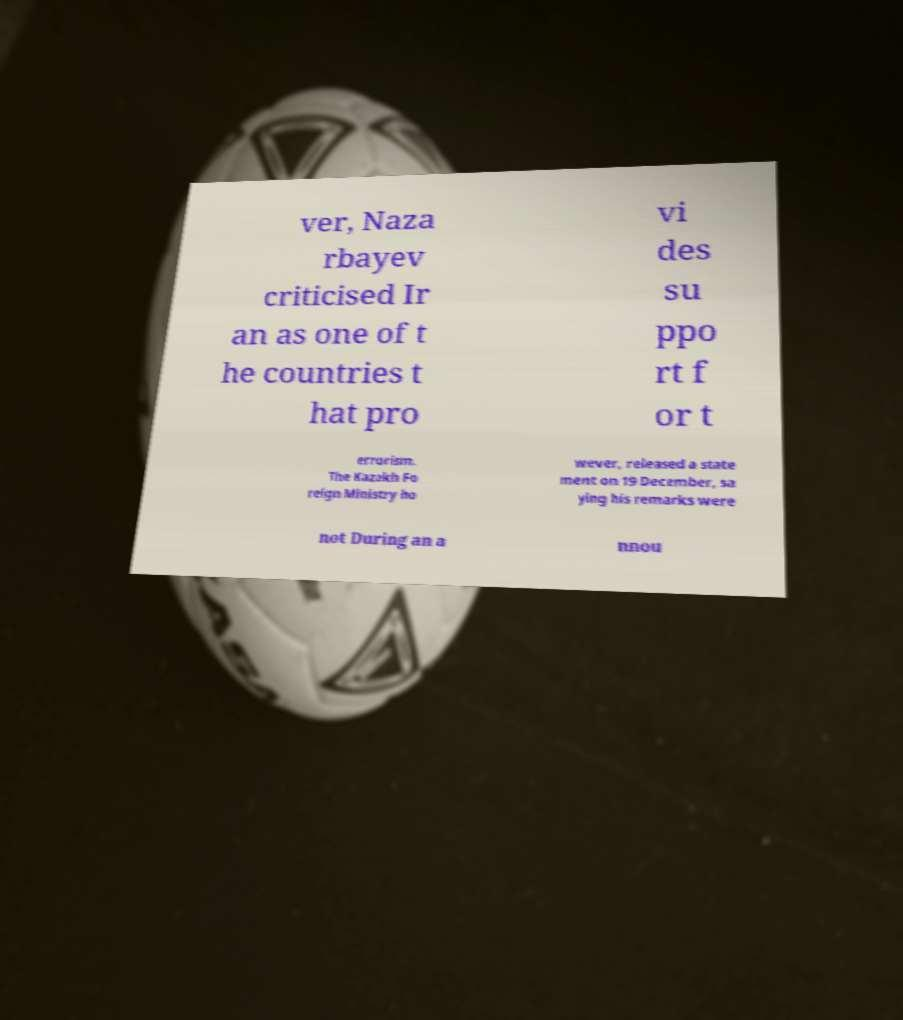What messages or text are displayed in this image? I need them in a readable, typed format. ver, Naza rbayev criticised Ir an as one of t he countries t hat pro vi des su ppo rt f or t errorism. The Kazakh Fo reign Ministry ho wever, released a state ment on 19 December, sa ying his remarks were not During an a nnou 